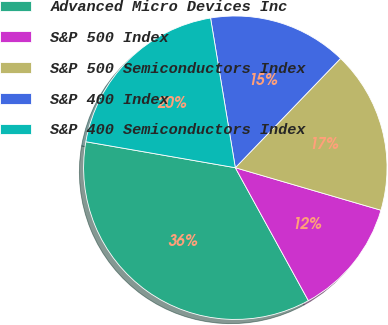Convert chart. <chart><loc_0><loc_0><loc_500><loc_500><pie_chart><fcel>Advanced Micro Devices Inc<fcel>S&P 500 Index<fcel>S&P 500 Semiconductors Index<fcel>S&P 400 Index<fcel>S&P 400 Semiconductors Index<nl><fcel>35.74%<fcel>12.48%<fcel>17.32%<fcel>14.81%<fcel>19.65%<nl></chart> 